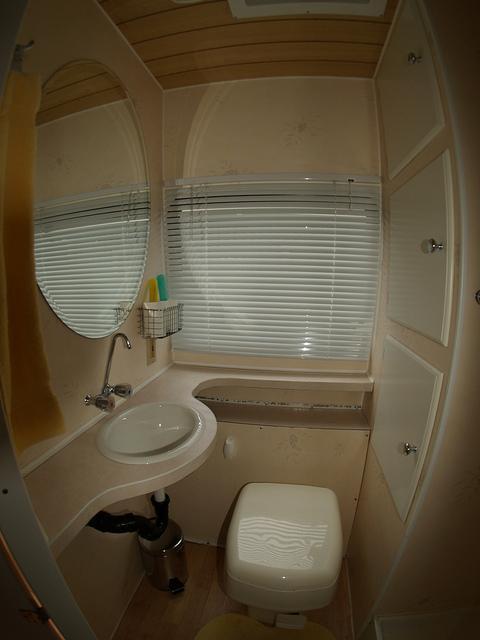How many cabinets are visible?
Give a very brief answer. 3. How many towels are in this picture?
Give a very brief answer. 0. How many people are standing in the truck?
Give a very brief answer. 0. 